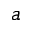Convert formula to latex. <formula><loc_0><loc_0><loc_500><loc_500>a</formula> 